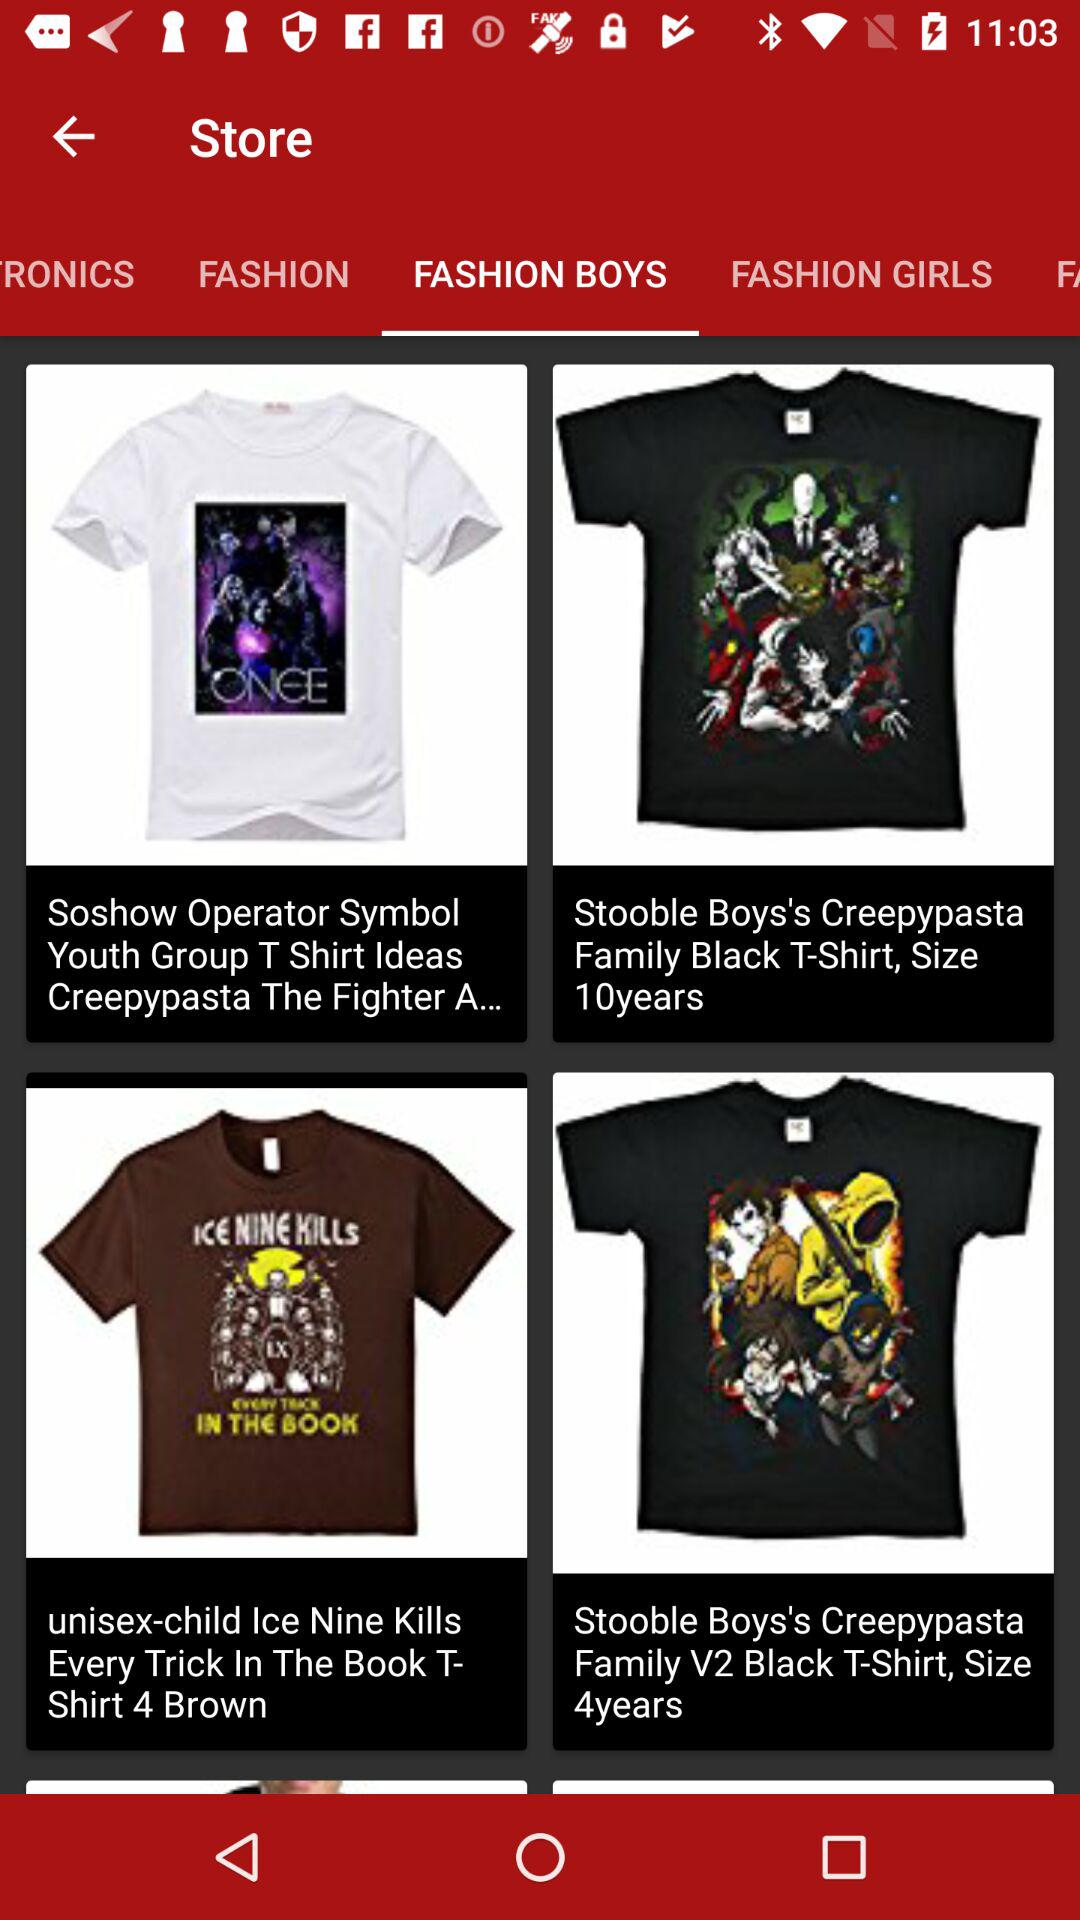Which clothing items are available in "FASHION GIRLS"?
When the provided information is insufficient, respond with <no answer>. <no answer> 